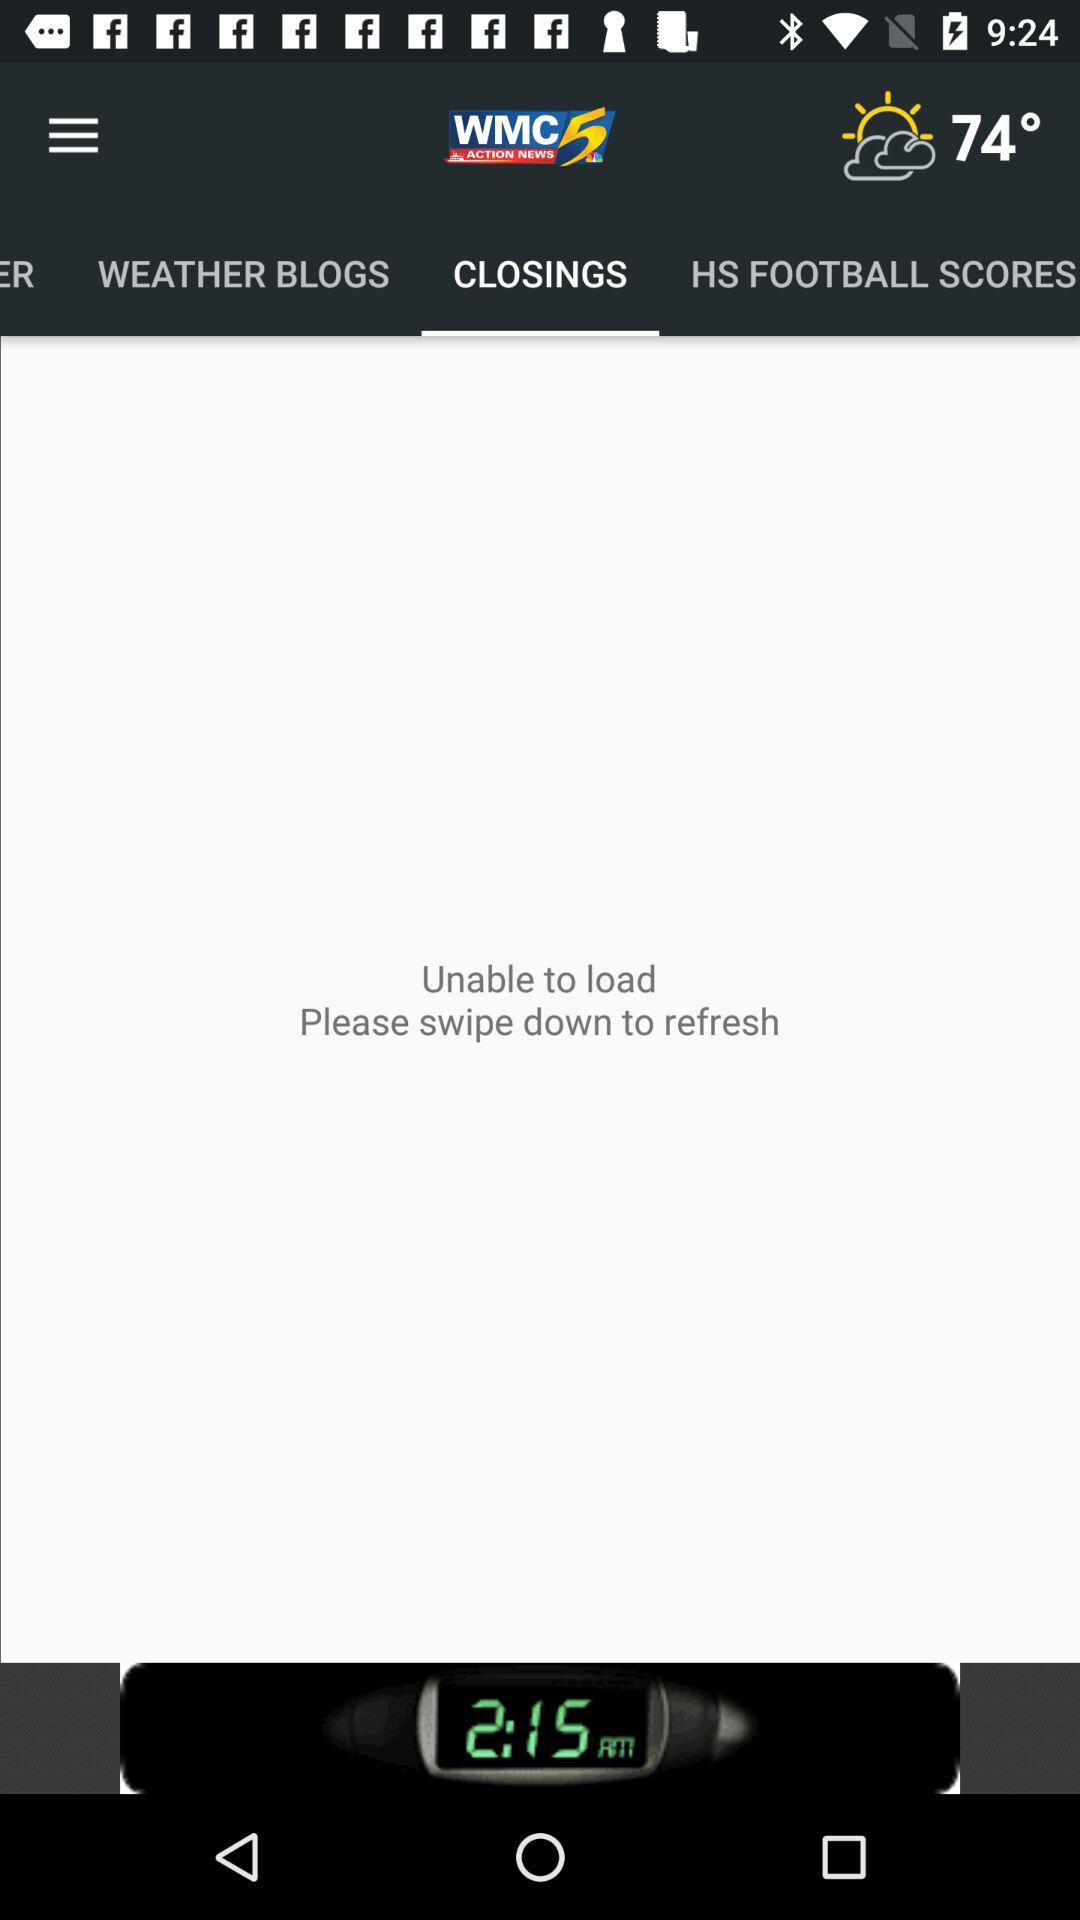What is the name of the application? The name of the application is "WMC ACTION NEWS 5". 